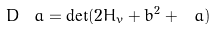<formula> <loc_0><loc_0><loc_500><loc_500>D _ { \ } a = \det ( 2 H _ { v } + b ^ { 2 } + \ a )</formula> 